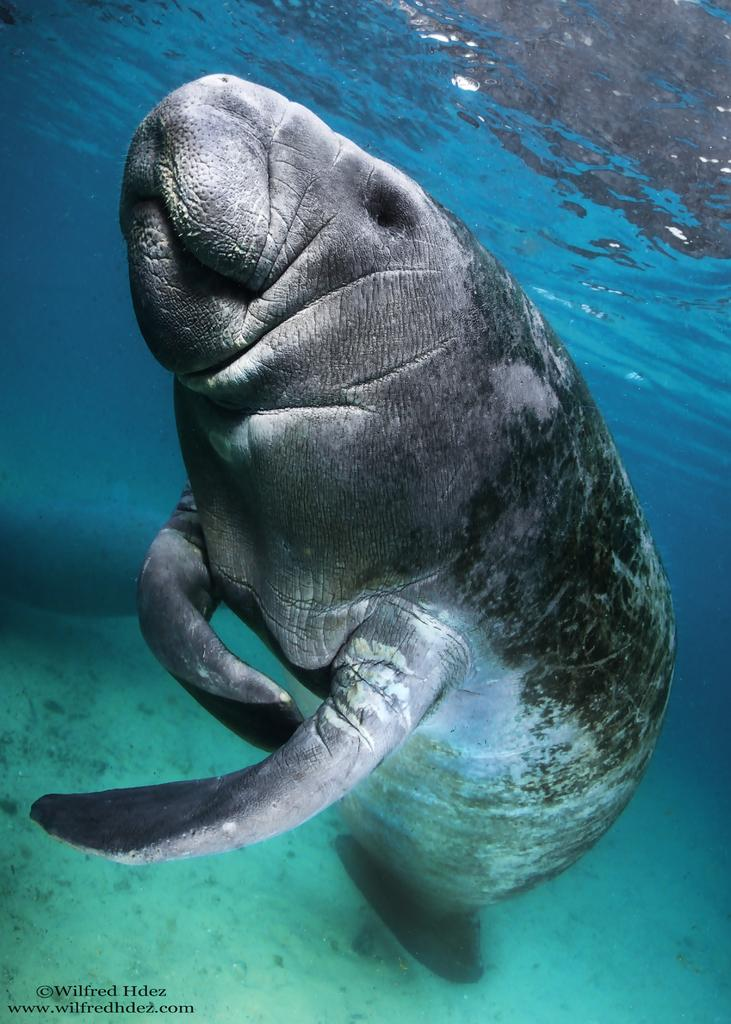Where was the image taken? The image is taken in the water. What can be seen in the middle of the image? There is a water mammal in the middle of the image. What is visible in the background of the image? There is water visible in the background of the image. What type of silk is being used by the star in the image? There is no silk or star present in the image; it features a water mammal in the water. How does the behavior of the water mammal change throughout the image? The image is a still photograph, so it does not show any changes in the behavior of the water mammal. 